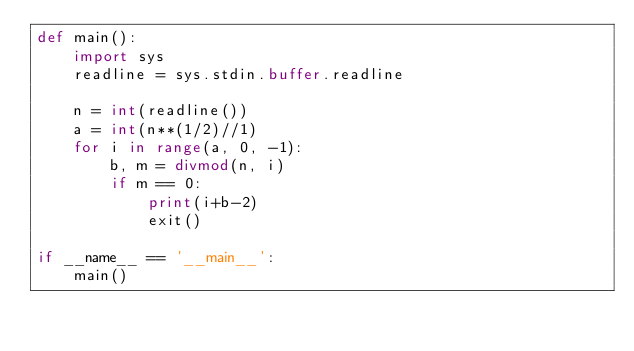<code> <loc_0><loc_0><loc_500><loc_500><_Python_>def main():
    import sys
    readline = sys.stdin.buffer.readline

    n = int(readline())
    a = int(n**(1/2)//1)
    for i in range(a, 0, -1):
        b, m = divmod(n, i)
        if m == 0:
            print(i+b-2)
            exit()

if __name__ == '__main__':
    main()</code> 